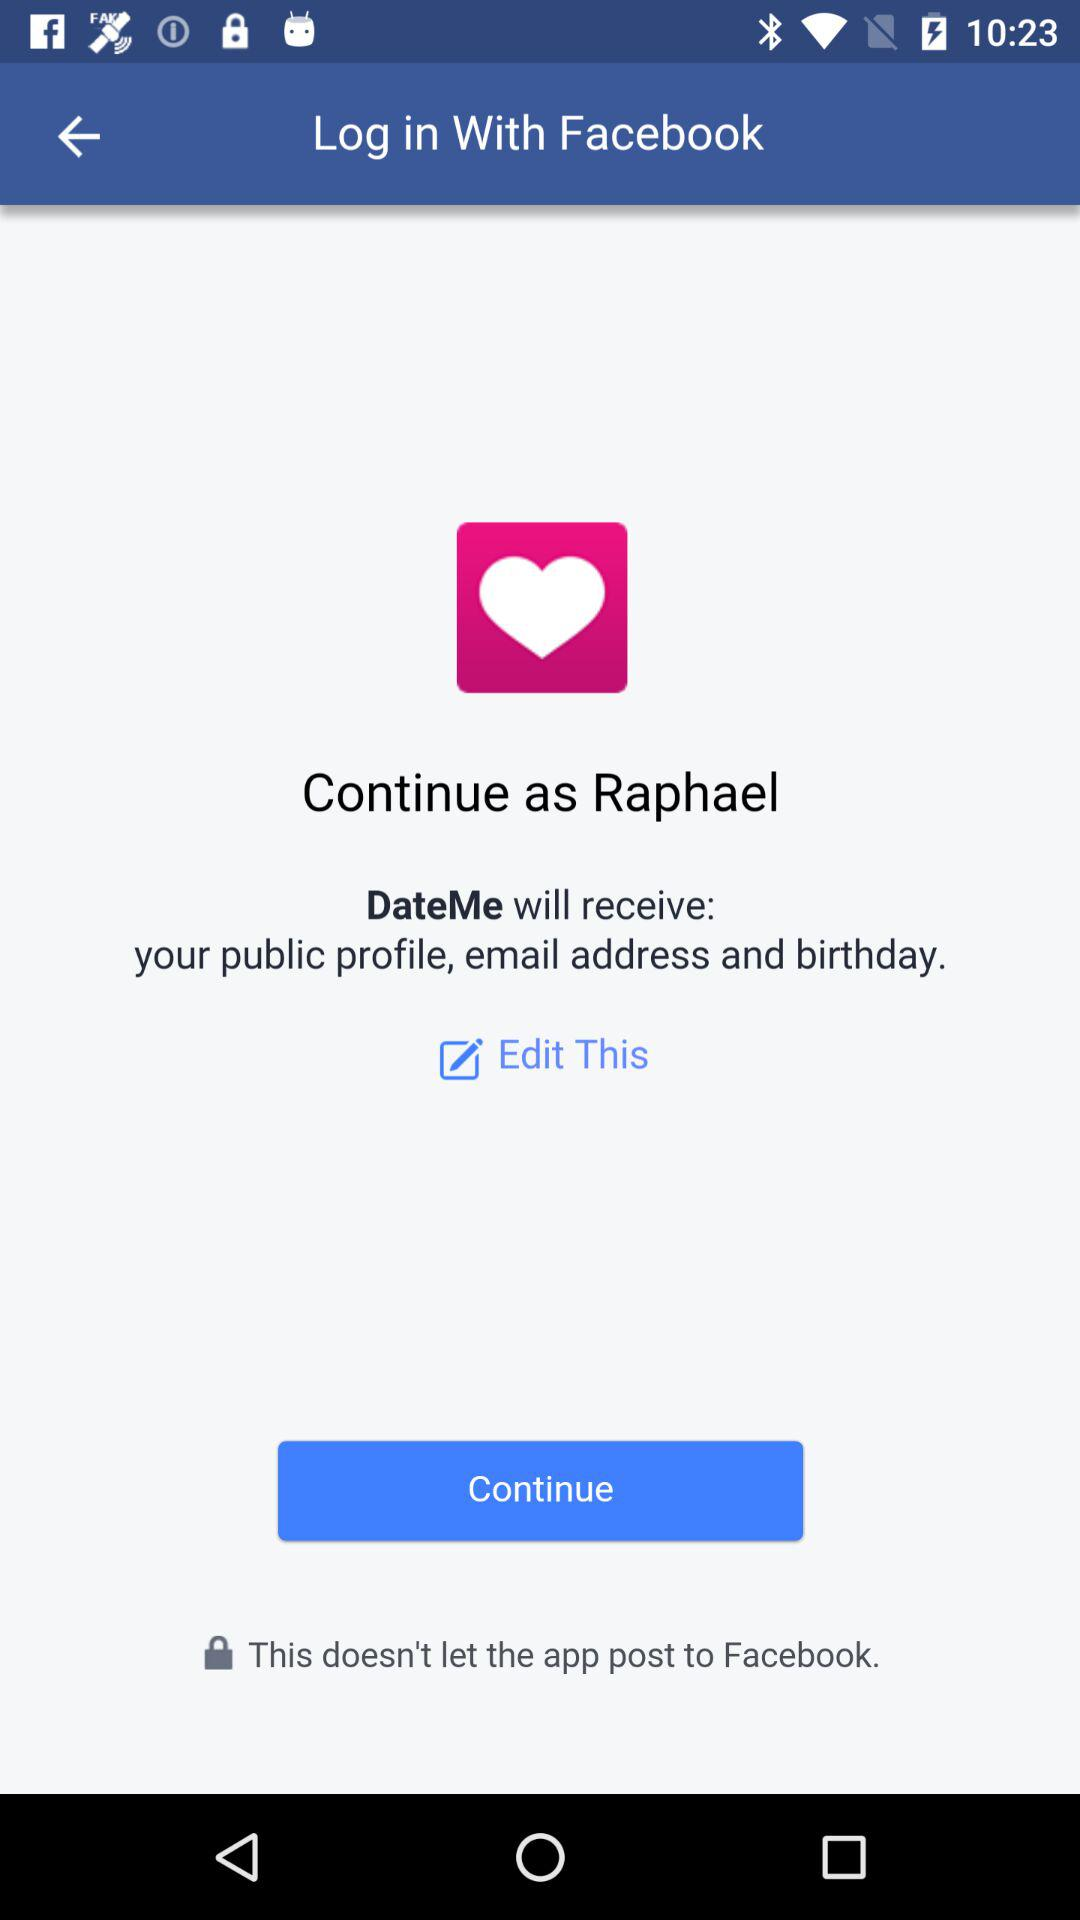What application is asking for permission? The application asking for permission is "DateMe". 